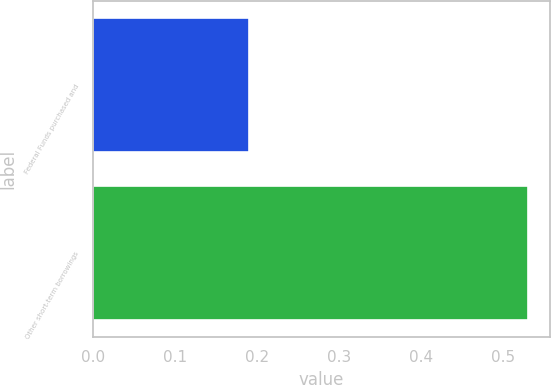<chart> <loc_0><loc_0><loc_500><loc_500><bar_chart><fcel>Federal Funds purchased and<fcel>Other short-term borrowings<nl><fcel>0.19<fcel>0.53<nl></chart> 